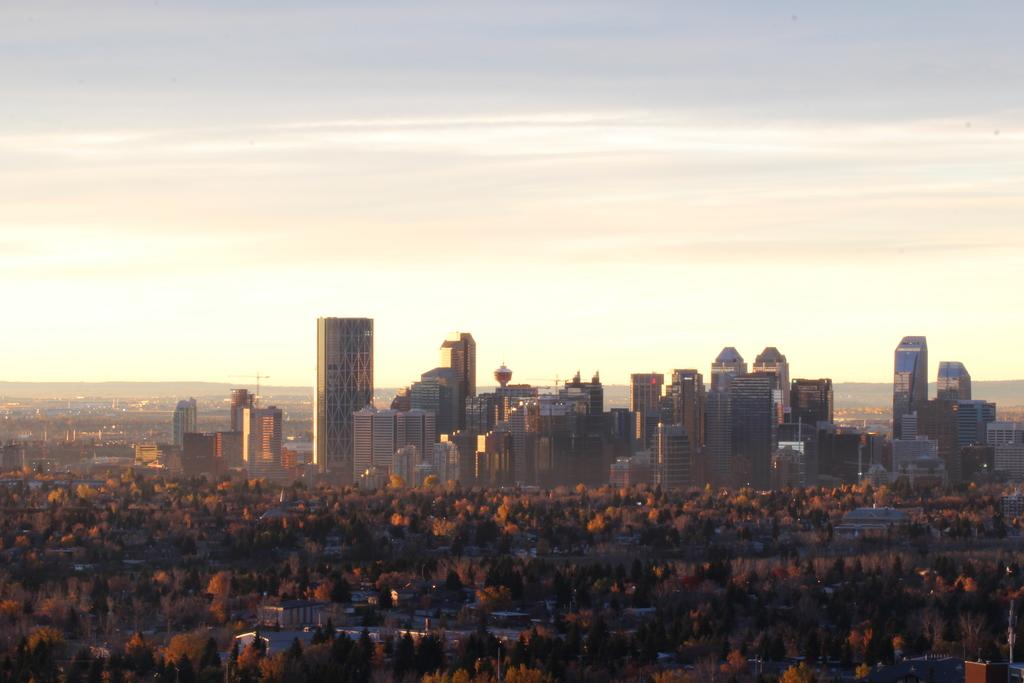What type of structures can be seen in the image? There are buildings in the image. What other natural elements are present in the image? There are trees in the image. What can be seen in the distance in the image? The sky is visible in the background of the image. How does the beginner learn to control their impulse in the image? There is no reference to a beginner or impulse control in the image; it simply features buildings, trees, and the sky. 